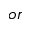Convert formula to latex. <formula><loc_0><loc_0><loc_500><loc_500>o r</formula> 